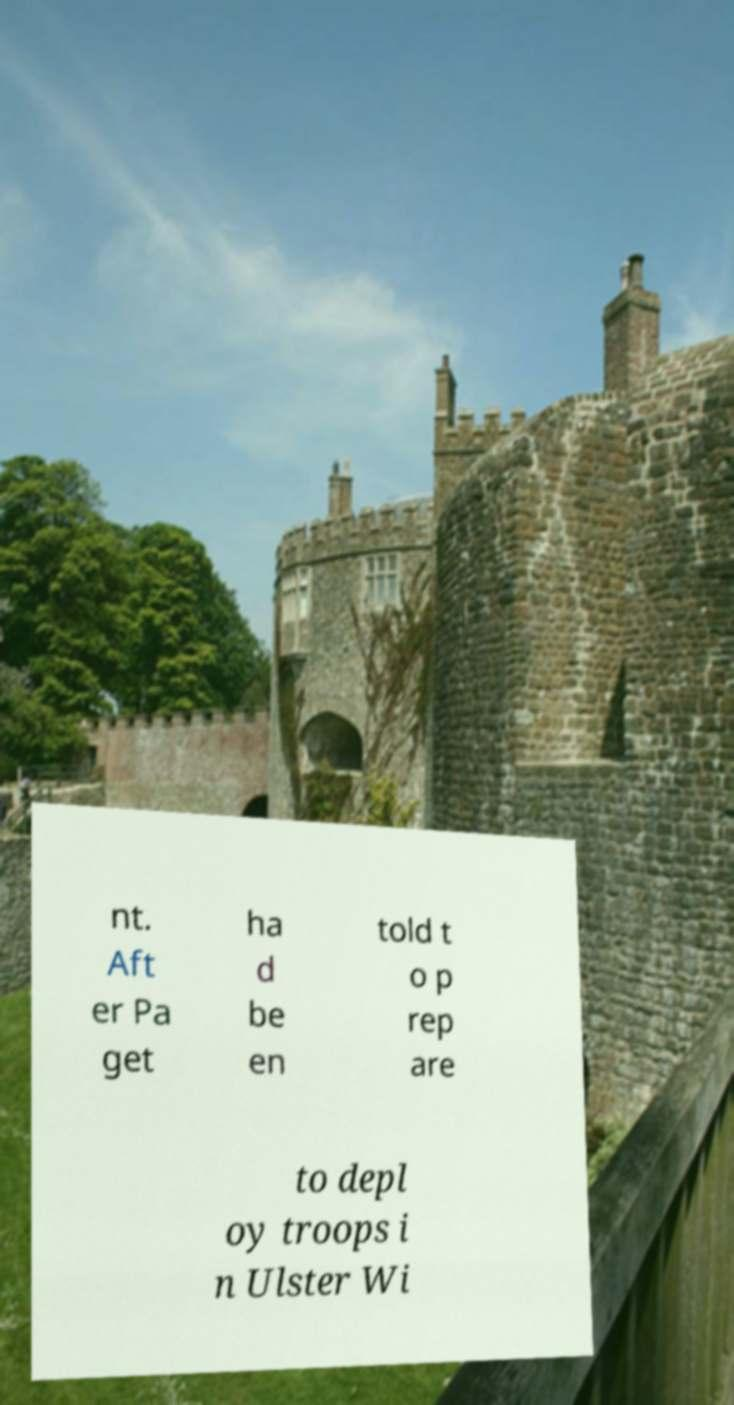Please identify and transcribe the text found in this image. nt. Aft er Pa get ha d be en told t o p rep are to depl oy troops i n Ulster Wi 